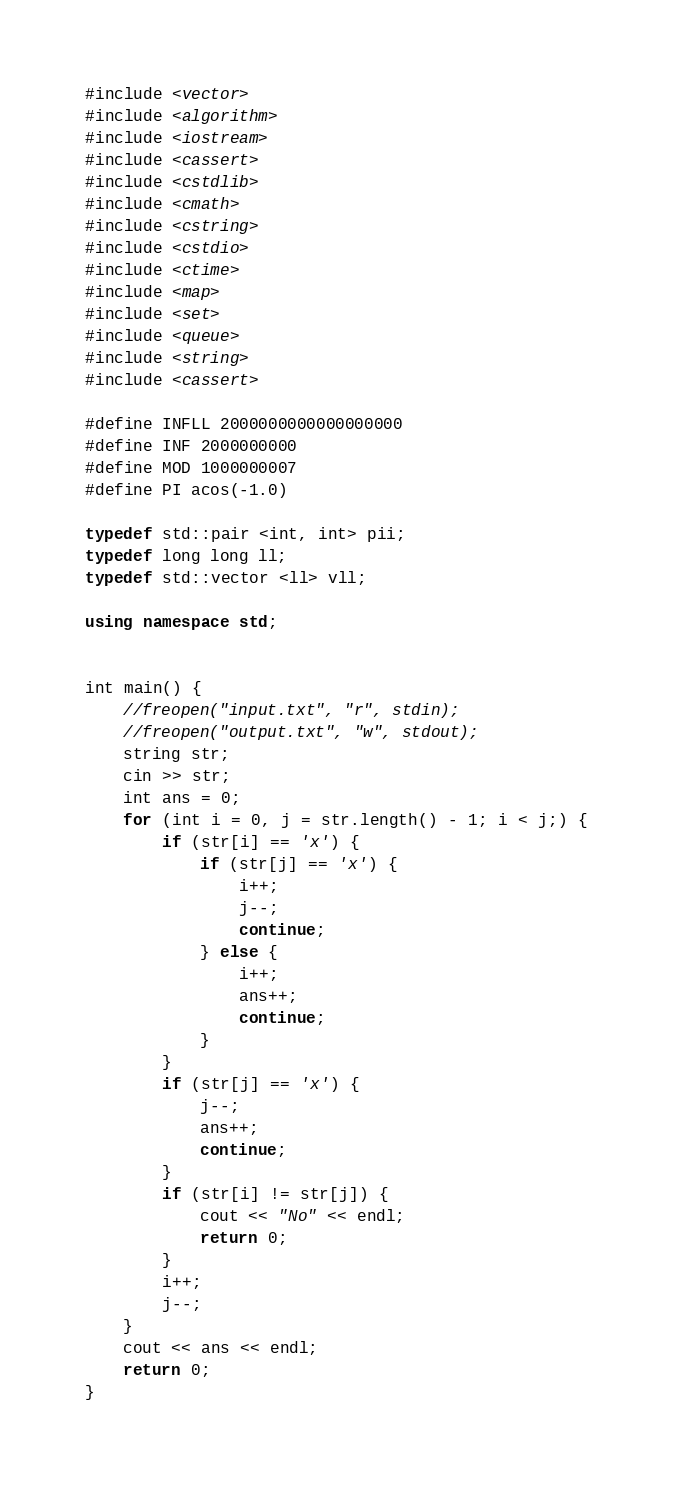<code> <loc_0><loc_0><loc_500><loc_500><_C++_>#include <vector>
#include <algorithm>
#include <iostream>
#include <cassert>
#include <cstdlib>
#include <cmath>
#include <cstring>
#include <cstdio>
#include <ctime>
#include <map>
#include <set>
#include <queue>
#include <string>
#include <cassert>

#define INFLL 2000000000000000000
#define INF 2000000000
#define MOD 1000000007
#define PI acos(-1.0)

typedef std::pair <int, int> pii;
typedef long long ll;
typedef std::vector <ll> vll;

using namespace std;


int main() {
	//freopen("input.txt", "r", stdin);
	//freopen("output.txt", "w", stdout);	
	string str;
	cin >> str;
	int ans = 0;
	for (int i = 0, j = str.length() - 1; i < j;) {
		if (str[i] == 'x') {
			if (str[j] == 'x') {
				i++;
				j--;
				continue;
			} else {
				i++;
				ans++;
				continue;
			}		
		}
		if (str[j] == 'x') {
			j--;
			ans++;
			continue;
		}
		if (str[i] != str[j]) {
			cout << "No" << endl;
			return 0;
		}
		i++;
		j--;
	}
	cout << ans << endl;
	return 0;
}</code> 